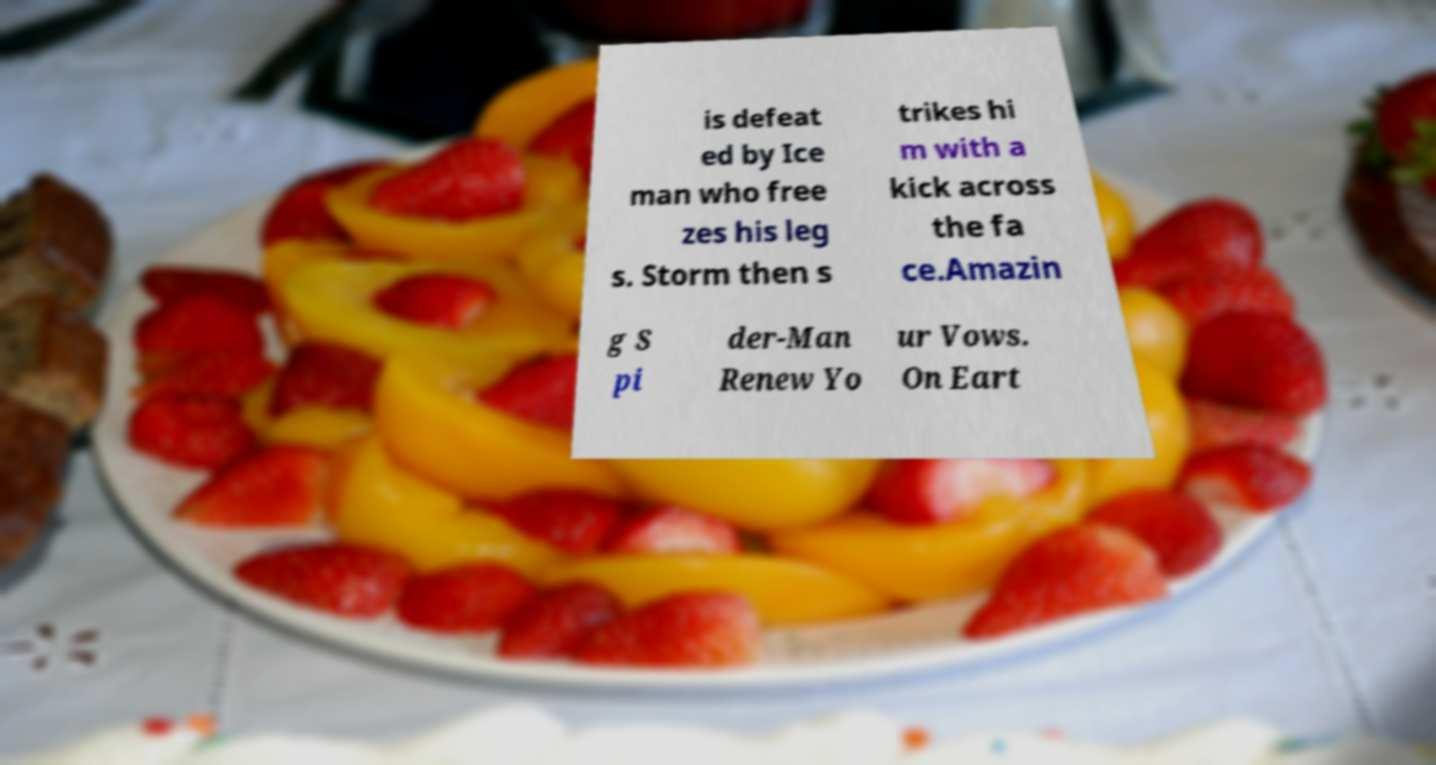Could you assist in decoding the text presented in this image and type it out clearly? is defeat ed by Ice man who free zes his leg s. Storm then s trikes hi m with a kick across the fa ce.Amazin g S pi der-Man Renew Yo ur Vows. On Eart 